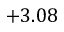<formula> <loc_0><loc_0><loc_500><loc_500>+ 3 . 0 8</formula> 